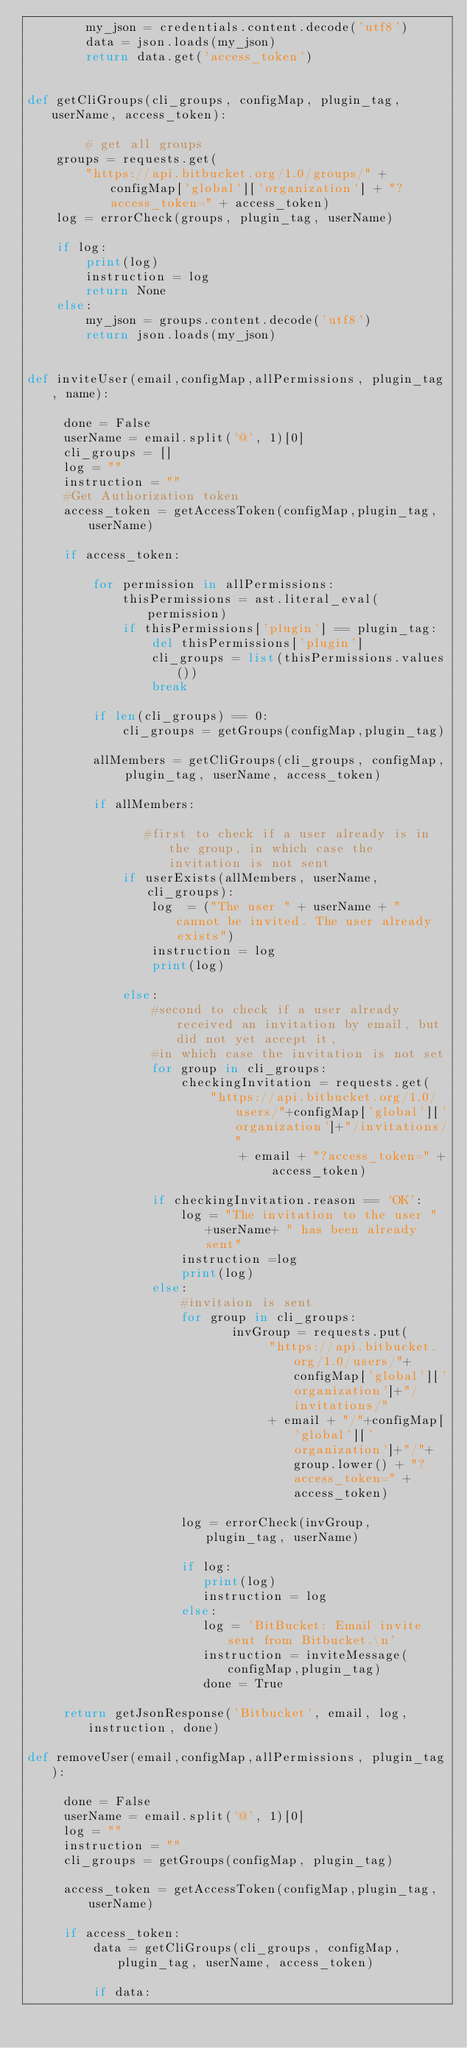Convert code to text. <code><loc_0><loc_0><loc_500><loc_500><_Python_>        my_json = credentials.content.decode('utf8')
        data = json.loads(my_json)
        return data.get('access_token')


def getCliGroups(cli_groups, configMap, plugin_tag, userName, access_token):

        # get all groups
    groups = requests.get(
        "https://api.bitbucket.org/1.0/groups/" + configMap['global']['organization'] + "?access_token=" + access_token)
    log = errorCheck(groups, plugin_tag, userName)

    if log:
        print(log)
        instruction = log
        return None
    else:
        my_json = groups.content.decode('utf8')
        return json.loads(my_json)


def inviteUser(email,configMap,allPermissions, plugin_tag, name):

     done = False
     userName = email.split('@', 1)[0]
     cli_groups = []
     log = ""
     instruction = ""
     #Get Authorization token
     access_token = getAccessToken(configMap,plugin_tag, userName)

     if access_token:

         for permission in allPermissions:
             thisPermissions = ast.literal_eval(permission)
             if thisPermissions['plugin'] == plugin_tag:
                 del thisPermissions['plugin']
                 cli_groups = list(thisPermissions.values())
                 break

         if len(cli_groups) == 0:
             cli_groups = getGroups(configMap,plugin_tag)

         allMembers = getCliGroups(cli_groups, configMap, plugin_tag, userName, access_token)

         if allMembers:

                #first to check if a user already is in the group, in which case the invitation is not sent
             if userExists(allMembers, userName, cli_groups):
                 log  = ("The user " + userName + " cannot be invited. The user already exists")
                 instruction = log
                 print(log)

             else:
                 #second to check if a user already received an invitation by email, but did not yet accept it,
                 #in which case the invitation is not set
                 for group in cli_groups:
                     checkingInvitation = requests.get(
                         "https://api.bitbucket.org/1.0/users/"+configMap['global']['organization']+"/invitations/"
                             + email + "?access_token=" + access_token)

                 if checkingInvitation.reason == 'OK':
                     log = "The invitation to the user " +userName+ " has been already sent"
                     instruction =log
                     print(log)
                 else:
                     #invitaion is sent
                     for group in cli_groups:
                            invGroup = requests.put(
                                 "https://api.bitbucket.org/1.0/users/"+configMap['global']['organization']+"/invitations/"
                                 + email + "/"+configMap['global']['organization']+"/"+group.lower() + "?access_token=" + access_token)

                     log = errorCheck(invGroup, plugin_tag, userName)

                     if log:
                        print(log)
                        instruction = log
                     else:
                        log = 'BitBucket: Email invite sent from Bitbucket.\n'
                        instruction = inviteMessage(configMap,plugin_tag)
                        done = True

     return getJsonResponse('Bitbucket', email, log, instruction, done)

def removeUser(email,configMap,allPermissions, plugin_tag):

     done = False
     userName = email.split('@', 1)[0]
     log = ""
     instruction = ""
     cli_groups = getGroups(configMap, plugin_tag)

     access_token = getAccessToken(configMap,plugin_tag, userName)

     if access_token:
         data = getCliGroups(cli_groups, configMap, plugin_tag, userName, access_token)

         if data:</code> 